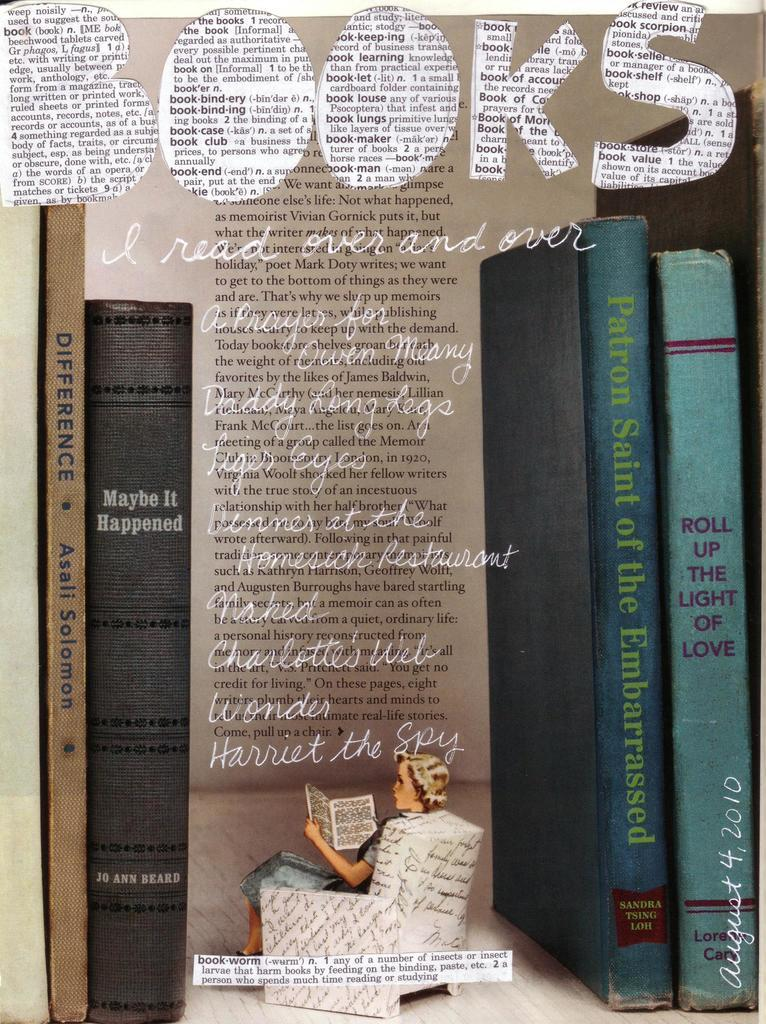<image>
Offer a succinct explanation of the picture presented. A few books that someone has read over and over with the definition of bookworm near the bottom of the poster. 